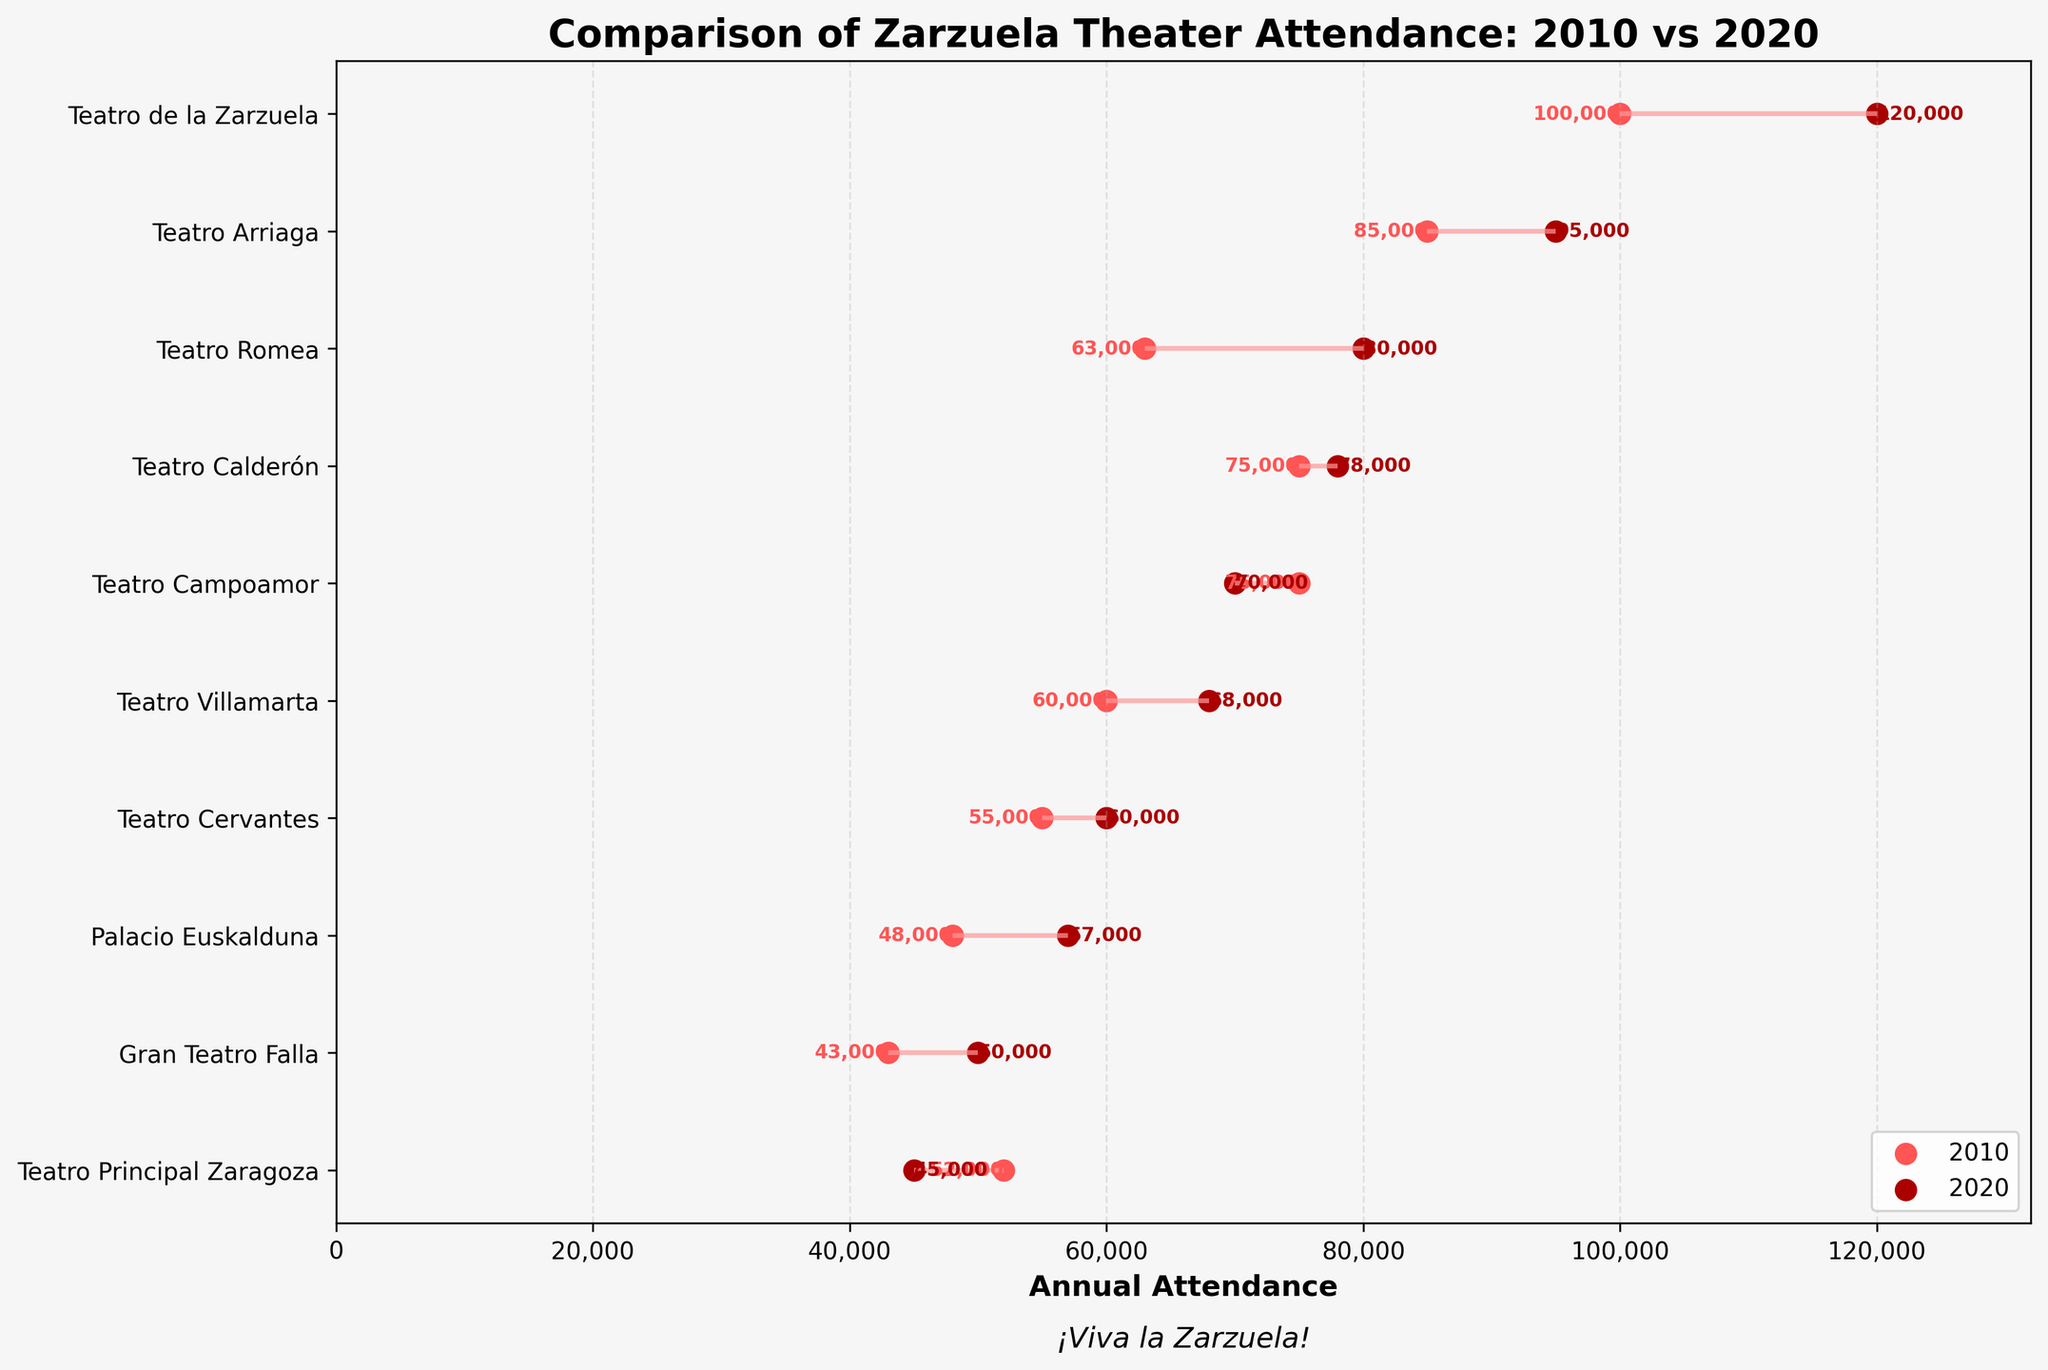What is the title of the plot? The title of the plot appears at the top of the figure and provides an overview of what the plot is about. The title reads "Comparison of Zarzuela Theater Attendance: 2010 vs 2020".
Answer: Comparison of Zarzuela Theater Attendance: 2010 vs 2020 Which theater had the highest attendance in 2020? To find the theater with the highest attendance in 2020, look for the theater with the rightmost dot (the one with the highest attendance number). Teatro de la Zarzuela has the highest 2020 attendance at 120,000.
Answer: Teatro de la Zarzuela What was the attendance difference for Teatro Principal Zaragoza from 2010 to 2020? To find this, look at the data points for Teatro Principal Zaragoza. In 2010, the attendance was 52,000, and in 2020 it was 45,000. The difference is 52,000 - 45,000 = 7,000.
Answer: 7,000 How many theaters had increased attendance from 2010 to 2020? Identify the number of theaters where the attendance dot in 2020 is to the right of the attendance dot in 2010. Five theaters (Teatro de la Zarzuela, Teatro Arriaga, Teatro Romea, Teatro Cervantes, Palacio Euskalduna) show increased attendance.
Answer: 5 Which theater experienced the largest attendance increase over the decade? To determine this, look for the longest horizontal line between the dots representing 2010 and 2020 attendance. Teatro de la Zarzuela had an increase from 100,000 to 120,000, so the increase is 20,000, which is the largest among all theaters.
Answer: Teatro de la Zarzuela What is the average attendance in 2020 for all theaters? Sum all the attendance numbers for 2020 and divide by the number of theaters. The sum is 120,000 + 95,000 + 70,000 + 80,000 + 60,000 + 57,000 + 50,000 + 45,000 + 68,000 + 78,000 = 723,000. There are 10 theaters, so the average is 723,000 / 10 = 72,300.
Answer: 72,300 Which theater had a decrease in attendance from 2010 to 2020? Identify the theaters where the attendance dot in 2020 is to the left of the attendance dot in 2010. Teatro Campoamor and Teatro Principal Zaragoza show decreased attendance.
Answer: Teatro Campoamor and Teatro Principal Zaragoza What is the average increase in attendance for theaters that had growth? First, find the increase for theaters with growth: Teatro de la Zarzuela (20,000), Teatro Arriaga (10,000), Teatro Romea (17,000), Teatro Cervantes (5,000), Palacio Euskalduna (9,000). The sum is 20,000 + 10,000 + 17,000 + 5,000 + 9,000 = 61,000, and there are 5 theaters, so the average increase is 61,000 / 5 = 12,200.
Answer: 12,200 Which theater had the smallest change in attendance, and what was it? Look for the shortest horizontal line between 2010 and 2020 attendance dots. Teatro Calderón had attendance of 75,000 in 2010 and 78,000 in 2020; the change is 78,000 - 75,000 = 3,000, which is the smallest change among all theaters.
Answer: Teatro Calderón, 3,000 